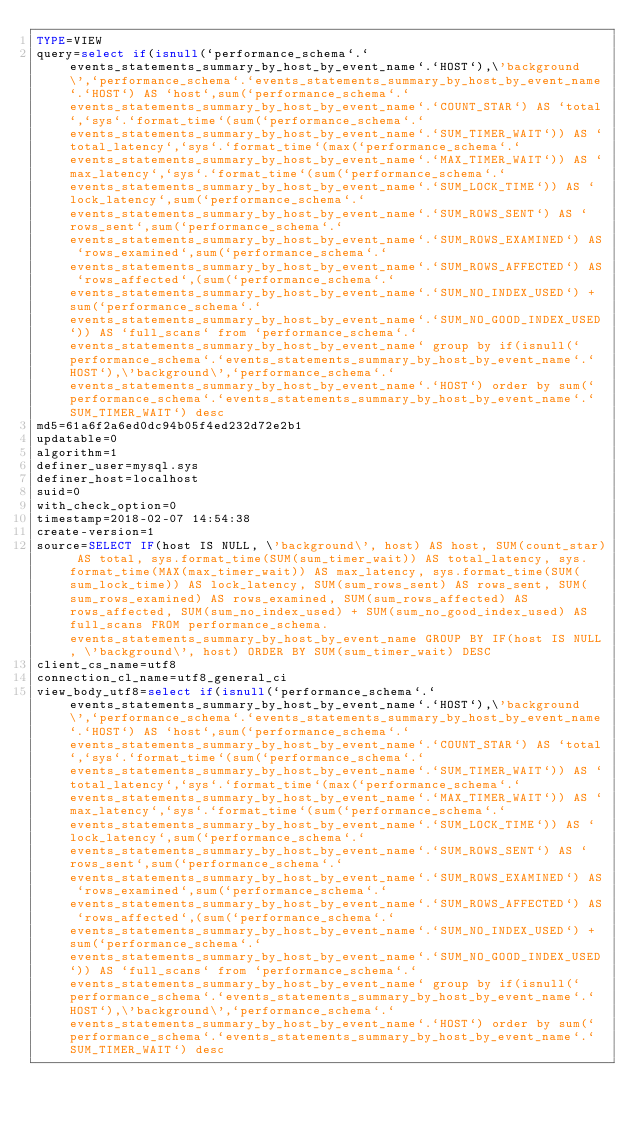<code> <loc_0><loc_0><loc_500><loc_500><_VisualBasic_>TYPE=VIEW
query=select if(isnull(`performance_schema`.`events_statements_summary_by_host_by_event_name`.`HOST`),\'background\',`performance_schema`.`events_statements_summary_by_host_by_event_name`.`HOST`) AS `host`,sum(`performance_schema`.`events_statements_summary_by_host_by_event_name`.`COUNT_STAR`) AS `total`,`sys`.`format_time`(sum(`performance_schema`.`events_statements_summary_by_host_by_event_name`.`SUM_TIMER_WAIT`)) AS `total_latency`,`sys`.`format_time`(max(`performance_schema`.`events_statements_summary_by_host_by_event_name`.`MAX_TIMER_WAIT`)) AS `max_latency`,`sys`.`format_time`(sum(`performance_schema`.`events_statements_summary_by_host_by_event_name`.`SUM_LOCK_TIME`)) AS `lock_latency`,sum(`performance_schema`.`events_statements_summary_by_host_by_event_name`.`SUM_ROWS_SENT`) AS `rows_sent`,sum(`performance_schema`.`events_statements_summary_by_host_by_event_name`.`SUM_ROWS_EXAMINED`) AS `rows_examined`,sum(`performance_schema`.`events_statements_summary_by_host_by_event_name`.`SUM_ROWS_AFFECTED`) AS `rows_affected`,(sum(`performance_schema`.`events_statements_summary_by_host_by_event_name`.`SUM_NO_INDEX_USED`) + sum(`performance_schema`.`events_statements_summary_by_host_by_event_name`.`SUM_NO_GOOD_INDEX_USED`)) AS `full_scans` from `performance_schema`.`events_statements_summary_by_host_by_event_name` group by if(isnull(`performance_schema`.`events_statements_summary_by_host_by_event_name`.`HOST`),\'background\',`performance_schema`.`events_statements_summary_by_host_by_event_name`.`HOST`) order by sum(`performance_schema`.`events_statements_summary_by_host_by_event_name`.`SUM_TIMER_WAIT`) desc
md5=61a6f2a6ed0dc94b05f4ed232d72e2b1
updatable=0
algorithm=1
definer_user=mysql.sys
definer_host=localhost
suid=0
with_check_option=0
timestamp=2018-02-07 14:54:38
create-version=1
source=SELECT IF(host IS NULL, \'background\', host) AS host, SUM(count_star) AS total, sys.format_time(SUM(sum_timer_wait)) AS total_latency, sys.format_time(MAX(max_timer_wait)) AS max_latency, sys.format_time(SUM(sum_lock_time)) AS lock_latency, SUM(sum_rows_sent) AS rows_sent, SUM(sum_rows_examined) AS rows_examined, SUM(sum_rows_affected) AS rows_affected, SUM(sum_no_index_used) + SUM(sum_no_good_index_used) AS full_scans FROM performance_schema.events_statements_summary_by_host_by_event_name GROUP BY IF(host IS NULL, \'background\', host) ORDER BY SUM(sum_timer_wait) DESC
client_cs_name=utf8
connection_cl_name=utf8_general_ci
view_body_utf8=select if(isnull(`performance_schema`.`events_statements_summary_by_host_by_event_name`.`HOST`),\'background\',`performance_schema`.`events_statements_summary_by_host_by_event_name`.`HOST`) AS `host`,sum(`performance_schema`.`events_statements_summary_by_host_by_event_name`.`COUNT_STAR`) AS `total`,`sys`.`format_time`(sum(`performance_schema`.`events_statements_summary_by_host_by_event_name`.`SUM_TIMER_WAIT`)) AS `total_latency`,`sys`.`format_time`(max(`performance_schema`.`events_statements_summary_by_host_by_event_name`.`MAX_TIMER_WAIT`)) AS `max_latency`,`sys`.`format_time`(sum(`performance_schema`.`events_statements_summary_by_host_by_event_name`.`SUM_LOCK_TIME`)) AS `lock_latency`,sum(`performance_schema`.`events_statements_summary_by_host_by_event_name`.`SUM_ROWS_SENT`) AS `rows_sent`,sum(`performance_schema`.`events_statements_summary_by_host_by_event_name`.`SUM_ROWS_EXAMINED`) AS `rows_examined`,sum(`performance_schema`.`events_statements_summary_by_host_by_event_name`.`SUM_ROWS_AFFECTED`) AS `rows_affected`,(sum(`performance_schema`.`events_statements_summary_by_host_by_event_name`.`SUM_NO_INDEX_USED`) + sum(`performance_schema`.`events_statements_summary_by_host_by_event_name`.`SUM_NO_GOOD_INDEX_USED`)) AS `full_scans` from `performance_schema`.`events_statements_summary_by_host_by_event_name` group by if(isnull(`performance_schema`.`events_statements_summary_by_host_by_event_name`.`HOST`),\'background\',`performance_schema`.`events_statements_summary_by_host_by_event_name`.`HOST`) order by sum(`performance_schema`.`events_statements_summary_by_host_by_event_name`.`SUM_TIMER_WAIT`) desc
</code> 